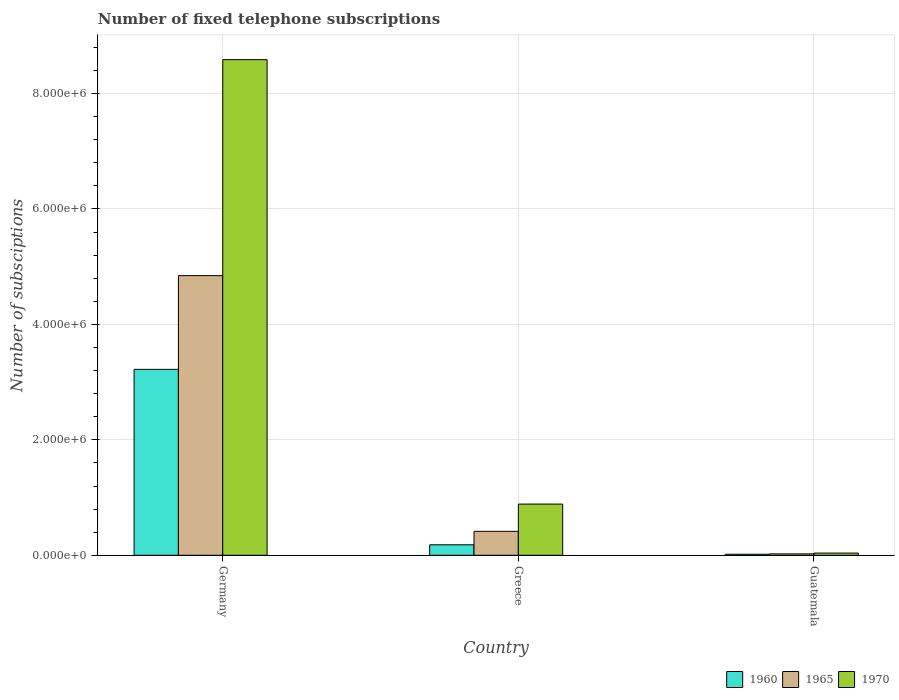Are the number of bars on each tick of the X-axis equal?
Your answer should be compact. Yes. How many bars are there on the 1st tick from the left?
Provide a succinct answer. 3. What is the number of fixed telephone subscriptions in 1970 in Germany?
Ensure brevity in your answer.  8.59e+06. Across all countries, what is the maximum number of fixed telephone subscriptions in 1970?
Offer a terse response. 8.59e+06. Across all countries, what is the minimum number of fixed telephone subscriptions in 1965?
Your response must be concise. 2.43e+04. In which country was the number of fixed telephone subscriptions in 1960 maximum?
Provide a succinct answer. Germany. In which country was the number of fixed telephone subscriptions in 1970 minimum?
Give a very brief answer. Guatemala. What is the total number of fixed telephone subscriptions in 1970 in the graph?
Provide a succinct answer. 9.51e+06. What is the difference between the number of fixed telephone subscriptions in 1970 in Germany and that in Guatemala?
Ensure brevity in your answer.  8.55e+06. What is the difference between the number of fixed telephone subscriptions in 1965 in Guatemala and the number of fixed telephone subscriptions in 1970 in Greece?
Give a very brief answer. -8.63e+05. What is the average number of fixed telephone subscriptions in 1965 per country?
Make the answer very short. 1.76e+06. What is the difference between the number of fixed telephone subscriptions of/in 1960 and number of fixed telephone subscriptions of/in 1970 in Guatemala?
Provide a short and direct response. -2.00e+04. In how many countries, is the number of fixed telephone subscriptions in 1960 greater than 1600000?
Provide a short and direct response. 1. What is the ratio of the number of fixed telephone subscriptions in 1965 in Germany to that in Greece?
Make the answer very short. 11.67. Is the number of fixed telephone subscriptions in 1960 in Greece less than that in Guatemala?
Ensure brevity in your answer.  No. Is the difference between the number of fixed telephone subscriptions in 1960 in Greece and Guatemala greater than the difference between the number of fixed telephone subscriptions in 1970 in Greece and Guatemala?
Give a very brief answer. No. What is the difference between the highest and the second highest number of fixed telephone subscriptions in 1965?
Provide a succinct answer. 4.43e+06. What is the difference between the highest and the lowest number of fixed telephone subscriptions in 1960?
Your answer should be compact. 3.20e+06. In how many countries, is the number of fixed telephone subscriptions in 1965 greater than the average number of fixed telephone subscriptions in 1965 taken over all countries?
Offer a terse response. 1. Is the sum of the number of fixed telephone subscriptions in 1965 in Germany and Guatemala greater than the maximum number of fixed telephone subscriptions in 1960 across all countries?
Offer a very short reply. Yes. What is the difference between two consecutive major ticks on the Y-axis?
Your answer should be very brief. 2.00e+06. Does the graph contain any zero values?
Provide a short and direct response. No. Where does the legend appear in the graph?
Provide a succinct answer. Bottom right. How are the legend labels stacked?
Offer a very short reply. Horizontal. What is the title of the graph?
Keep it short and to the point. Number of fixed telephone subscriptions. Does "2008" appear as one of the legend labels in the graph?
Your answer should be compact. No. What is the label or title of the Y-axis?
Provide a succinct answer. Number of subsciptions. What is the Number of subsciptions in 1960 in Germany?
Offer a very short reply. 3.22e+06. What is the Number of subsciptions of 1965 in Germany?
Make the answer very short. 4.84e+06. What is the Number of subsciptions in 1970 in Germany?
Your answer should be compact. 8.59e+06. What is the Number of subsciptions of 1960 in Greece?
Make the answer very short. 1.82e+05. What is the Number of subsciptions of 1965 in Greece?
Ensure brevity in your answer.  4.15e+05. What is the Number of subsciptions of 1970 in Greece?
Your answer should be compact. 8.87e+05. What is the Number of subsciptions of 1960 in Guatemala?
Offer a very short reply. 1.78e+04. What is the Number of subsciptions of 1965 in Guatemala?
Make the answer very short. 2.43e+04. What is the Number of subsciptions in 1970 in Guatemala?
Offer a very short reply. 3.79e+04. Across all countries, what is the maximum Number of subsciptions of 1960?
Your response must be concise. 3.22e+06. Across all countries, what is the maximum Number of subsciptions in 1965?
Provide a short and direct response. 4.84e+06. Across all countries, what is the maximum Number of subsciptions of 1970?
Give a very brief answer. 8.59e+06. Across all countries, what is the minimum Number of subsciptions of 1960?
Your response must be concise. 1.78e+04. Across all countries, what is the minimum Number of subsciptions in 1965?
Offer a terse response. 2.43e+04. Across all countries, what is the minimum Number of subsciptions in 1970?
Provide a short and direct response. 3.79e+04. What is the total Number of subsciptions of 1960 in the graph?
Offer a very short reply. 3.42e+06. What is the total Number of subsciptions in 1965 in the graph?
Give a very brief answer. 5.28e+06. What is the total Number of subsciptions in 1970 in the graph?
Keep it short and to the point. 9.51e+06. What is the difference between the Number of subsciptions in 1960 in Germany and that in Greece?
Offer a very short reply. 3.04e+06. What is the difference between the Number of subsciptions of 1965 in Germany and that in Greece?
Your answer should be compact. 4.43e+06. What is the difference between the Number of subsciptions of 1970 in Germany and that in Greece?
Your response must be concise. 7.70e+06. What is the difference between the Number of subsciptions of 1960 in Germany and that in Guatemala?
Give a very brief answer. 3.20e+06. What is the difference between the Number of subsciptions of 1965 in Germany and that in Guatemala?
Provide a succinct answer. 4.82e+06. What is the difference between the Number of subsciptions in 1970 in Germany and that in Guatemala?
Provide a succinct answer. 8.55e+06. What is the difference between the Number of subsciptions of 1960 in Greece and that in Guatemala?
Offer a terse response. 1.64e+05. What is the difference between the Number of subsciptions of 1965 in Greece and that in Guatemala?
Your answer should be compact. 3.91e+05. What is the difference between the Number of subsciptions of 1970 in Greece and that in Guatemala?
Your answer should be very brief. 8.49e+05. What is the difference between the Number of subsciptions of 1960 in Germany and the Number of subsciptions of 1965 in Greece?
Your answer should be compact. 2.81e+06. What is the difference between the Number of subsciptions of 1960 in Germany and the Number of subsciptions of 1970 in Greece?
Ensure brevity in your answer.  2.33e+06. What is the difference between the Number of subsciptions of 1965 in Germany and the Number of subsciptions of 1970 in Greece?
Ensure brevity in your answer.  3.96e+06. What is the difference between the Number of subsciptions in 1960 in Germany and the Number of subsciptions in 1965 in Guatemala?
Provide a short and direct response. 3.20e+06. What is the difference between the Number of subsciptions in 1960 in Germany and the Number of subsciptions in 1970 in Guatemala?
Give a very brief answer. 3.18e+06. What is the difference between the Number of subsciptions of 1965 in Germany and the Number of subsciptions of 1970 in Guatemala?
Provide a succinct answer. 4.81e+06. What is the difference between the Number of subsciptions in 1960 in Greece and the Number of subsciptions in 1965 in Guatemala?
Ensure brevity in your answer.  1.57e+05. What is the difference between the Number of subsciptions in 1960 in Greece and the Number of subsciptions in 1970 in Guatemala?
Offer a very short reply. 1.44e+05. What is the difference between the Number of subsciptions of 1965 in Greece and the Number of subsciptions of 1970 in Guatemala?
Your answer should be compact. 3.77e+05. What is the average Number of subsciptions in 1960 per country?
Make the answer very short. 1.14e+06. What is the average Number of subsciptions in 1965 per country?
Your answer should be compact. 1.76e+06. What is the average Number of subsciptions in 1970 per country?
Your response must be concise. 3.17e+06. What is the difference between the Number of subsciptions in 1960 and Number of subsciptions in 1965 in Germany?
Your answer should be very brief. -1.62e+06. What is the difference between the Number of subsciptions in 1960 and Number of subsciptions in 1970 in Germany?
Offer a very short reply. -5.37e+06. What is the difference between the Number of subsciptions of 1965 and Number of subsciptions of 1970 in Germany?
Offer a very short reply. -3.74e+06. What is the difference between the Number of subsciptions of 1960 and Number of subsciptions of 1965 in Greece?
Give a very brief answer. -2.33e+05. What is the difference between the Number of subsciptions in 1960 and Number of subsciptions in 1970 in Greece?
Make the answer very short. -7.05e+05. What is the difference between the Number of subsciptions in 1965 and Number of subsciptions in 1970 in Greece?
Your response must be concise. -4.72e+05. What is the difference between the Number of subsciptions in 1960 and Number of subsciptions in 1965 in Guatemala?
Your answer should be very brief. -6485. What is the difference between the Number of subsciptions in 1960 and Number of subsciptions in 1970 in Guatemala?
Your response must be concise. -2.00e+04. What is the difference between the Number of subsciptions in 1965 and Number of subsciptions in 1970 in Guatemala?
Your response must be concise. -1.36e+04. What is the ratio of the Number of subsciptions of 1960 in Germany to that in Greece?
Keep it short and to the point. 17.72. What is the ratio of the Number of subsciptions in 1965 in Germany to that in Greece?
Your response must be concise. 11.67. What is the ratio of the Number of subsciptions of 1970 in Germany to that in Greece?
Your answer should be very brief. 9.68. What is the ratio of the Number of subsciptions in 1960 in Germany to that in Guatemala?
Provide a succinct answer. 180.74. What is the ratio of the Number of subsciptions of 1965 in Germany to that in Guatemala?
Your answer should be very brief. 199.33. What is the ratio of the Number of subsciptions in 1970 in Germany to that in Guatemala?
Provide a short and direct response. 226.74. What is the ratio of the Number of subsciptions in 1960 in Greece to that in Guatemala?
Ensure brevity in your answer.  10.2. What is the ratio of the Number of subsciptions in 1965 in Greece to that in Guatemala?
Give a very brief answer. 17.07. What is the ratio of the Number of subsciptions in 1970 in Greece to that in Guatemala?
Offer a very short reply. 23.42. What is the difference between the highest and the second highest Number of subsciptions of 1960?
Make the answer very short. 3.04e+06. What is the difference between the highest and the second highest Number of subsciptions in 1965?
Offer a very short reply. 4.43e+06. What is the difference between the highest and the second highest Number of subsciptions of 1970?
Your response must be concise. 7.70e+06. What is the difference between the highest and the lowest Number of subsciptions in 1960?
Keep it short and to the point. 3.20e+06. What is the difference between the highest and the lowest Number of subsciptions of 1965?
Ensure brevity in your answer.  4.82e+06. What is the difference between the highest and the lowest Number of subsciptions in 1970?
Provide a succinct answer. 8.55e+06. 